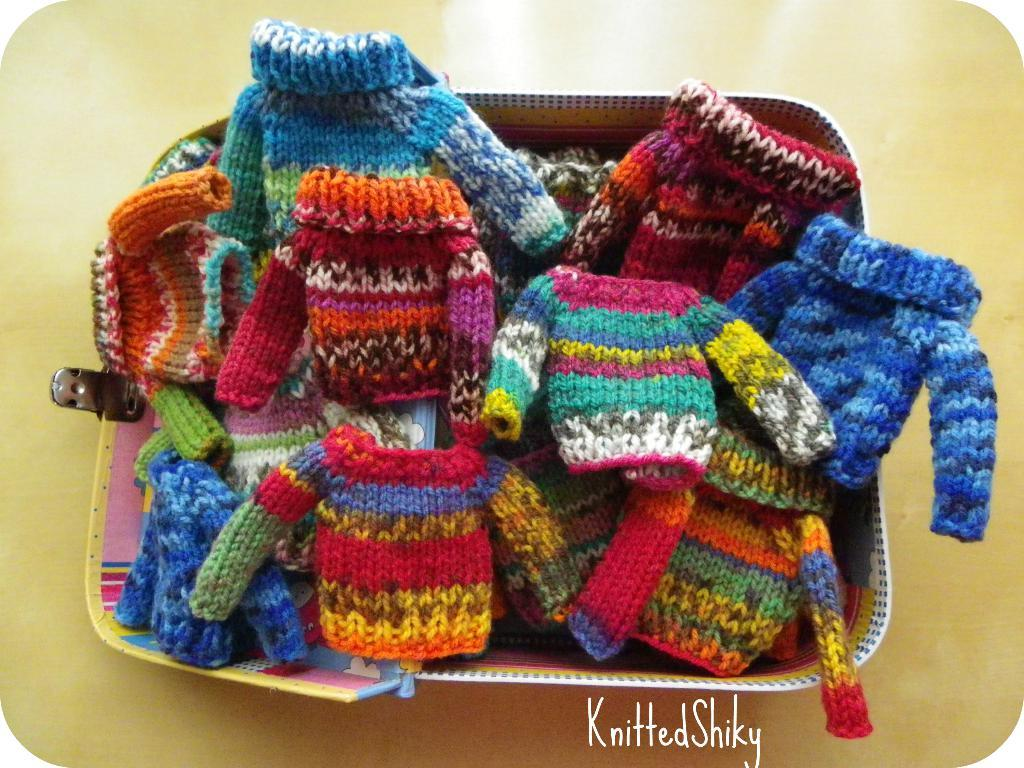What is in the basket that is visible in the image? There are clothes in a basket in the image. What type of iron is used to cook dinner in the image? There is no iron or dinner present in the image; it only features clothes in a basket. 